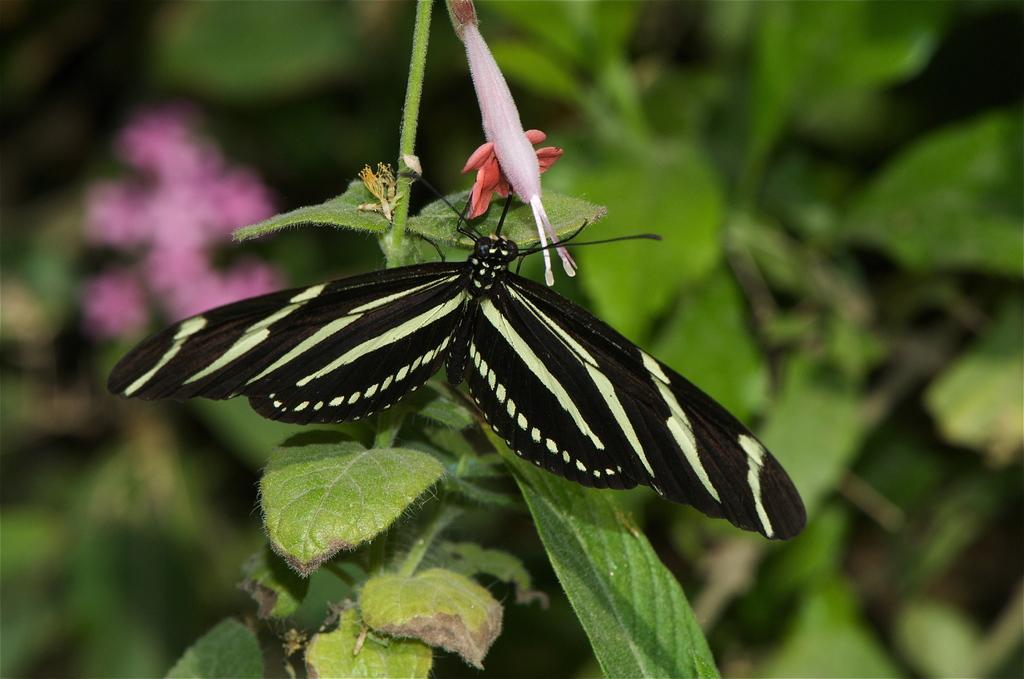Describe this image in one or two sentences. In the center of the image we can see one plant and one flower, which is in pink and orange color. On the plant, we can see one butterfly, which is in black and cream color. In the background we can see plants and flowers, which are in pink color. 